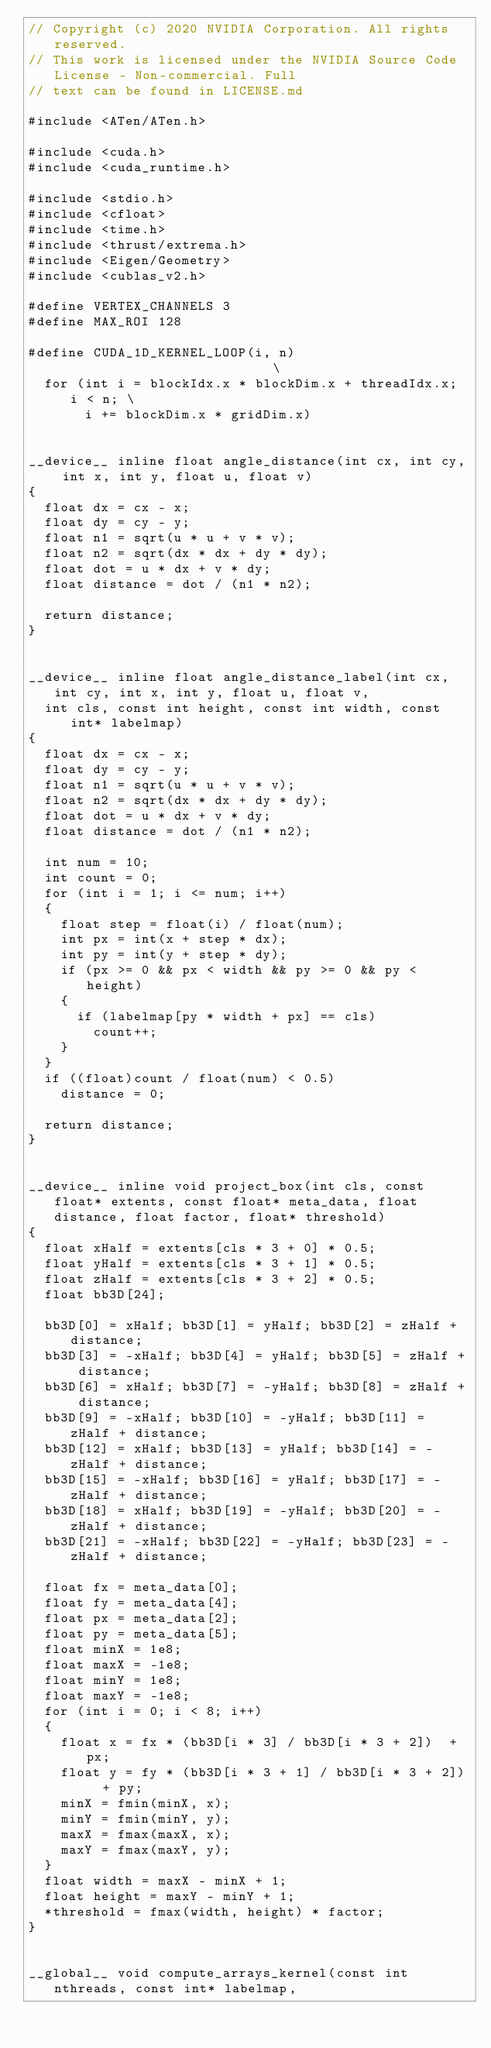<code> <loc_0><loc_0><loc_500><loc_500><_Cuda_>// Copyright (c) 2020 NVIDIA Corporation. All rights reserved.
// This work is licensed under the NVIDIA Source Code License - Non-commercial. Full
// text can be found in LICENSE.md

#include <ATen/ATen.h>

#include <cuda.h>
#include <cuda_runtime.h>

#include <stdio.h>
#include <cfloat>
#include <time.h>
#include <thrust/extrema.h>
#include <Eigen/Geometry> 
#include <cublas_v2.h>

#define VERTEX_CHANNELS 3
#define MAX_ROI 128

#define CUDA_1D_KERNEL_LOOP(i, n)                            \
  for (int i = blockIdx.x * blockDim.x + threadIdx.x; i < n; \
       i += blockDim.x * gridDim.x)


__device__ inline float angle_distance(int cx, int cy, int x, int y, float u, float v)
{
  float dx = cx - x;
  float dy = cy - y;
  float n1 = sqrt(u * u + v * v);
  float n2 = sqrt(dx * dx + dy * dy);
  float dot = u * dx + v * dy;
  float distance = dot / (n1 * n2);

  return distance;
}


__device__ inline float angle_distance_label(int cx, int cy, int x, int y, float u, float v,
  int cls, const int height, const int width, const int* labelmap)
{
  float dx = cx - x;
  float dy = cy - y;
  float n1 = sqrt(u * u + v * v);
  float n2 = sqrt(dx * dx + dy * dy);
  float dot = u * dx + v * dy;
  float distance = dot / (n1 * n2);

  int num = 10;
  int count = 0;
  for (int i = 1; i <= num; i++)
  {
    float step = float(i) / float(num);
    int px = int(x + step * dx);
    int py = int(y + step * dy);
    if (px >= 0 && px < width && py >= 0 && py < height)
    {
      if (labelmap[py * width + px] == cls)
        count++;
    }
  }
  if ((float)count / float(num) < 0.5)
    distance = 0;

  return distance;
}


__device__ inline void project_box(int cls, const float* extents, const float* meta_data, float distance, float factor, float* threshold)
{
  float xHalf = extents[cls * 3 + 0] * 0.5;
  float yHalf = extents[cls * 3 + 1] * 0.5;
  float zHalf = extents[cls * 3 + 2] * 0.5;
  float bb3D[24];

  bb3D[0] = xHalf; bb3D[1] = yHalf; bb3D[2] = zHalf + distance;
  bb3D[3] = -xHalf; bb3D[4] = yHalf; bb3D[5] = zHalf + distance;
  bb3D[6] = xHalf; bb3D[7] = -yHalf; bb3D[8] = zHalf + distance;
  bb3D[9] = -xHalf; bb3D[10] = -yHalf; bb3D[11] = zHalf + distance;
  bb3D[12] = xHalf; bb3D[13] = yHalf; bb3D[14] = -zHalf + distance;
  bb3D[15] = -xHalf; bb3D[16] = yHalf; bb3D[17] = -zHalf + distance;
  bb3D[18] = xHalf; bb3D[19] = -yHalf; bb3D[20] = -zHalf + distance;
  bb3D[21] = -xHalf; bb3D[22] = -yHalf; bb3D[23] = -zHalf + distance;

  float fx = meta_data[0];
  float fy = meta_data[4];
  float px = meta_data[2];
  float py = meta_data[5];
  float minX = 1e8;
  float maxX = -1e8;
  float minY = 1e8;
  float maxY = -1e8;
  for (int i = 0; i < 8; i++)
  {
    float x = fx * (bb3D[i * 3] / bb3D[i * 3 + 2])  + px;
    float y = fy * (bb3D[i * 3 + 1] / bb3D[i * 3 + 2])  + py;
    minX = fmin(minX, x);
    minY = fmin(minY, y);
    maxX = fmax(maxX, x);
    maxY = fmax(maxY, y);
  }
  float width = maxX - minX + 1;
  float height = maxY - minY + 1;
  *threshold = fmax(width, height) * factor;
}


__global__ void compute_arrays_kernel(const int nthreads, const int* labelmap,</code> 